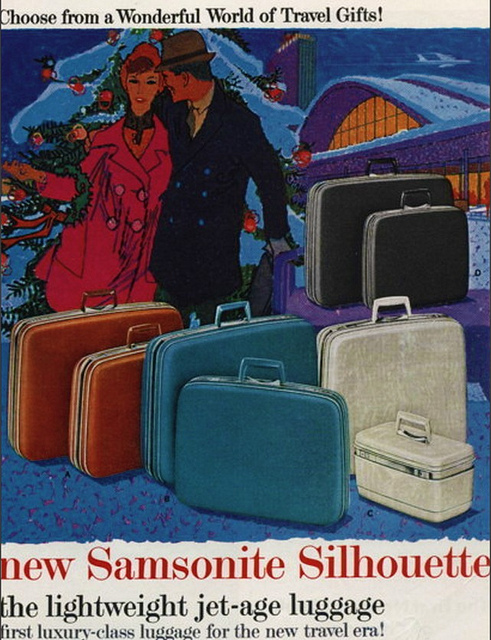What kind of luggage is being advertised? The advertisement showcases a variety of Samsonite Silhouette luggage, described as 'the lightweight jet-age luggage,' suggesting sophistication and travel ease for the modern era. 